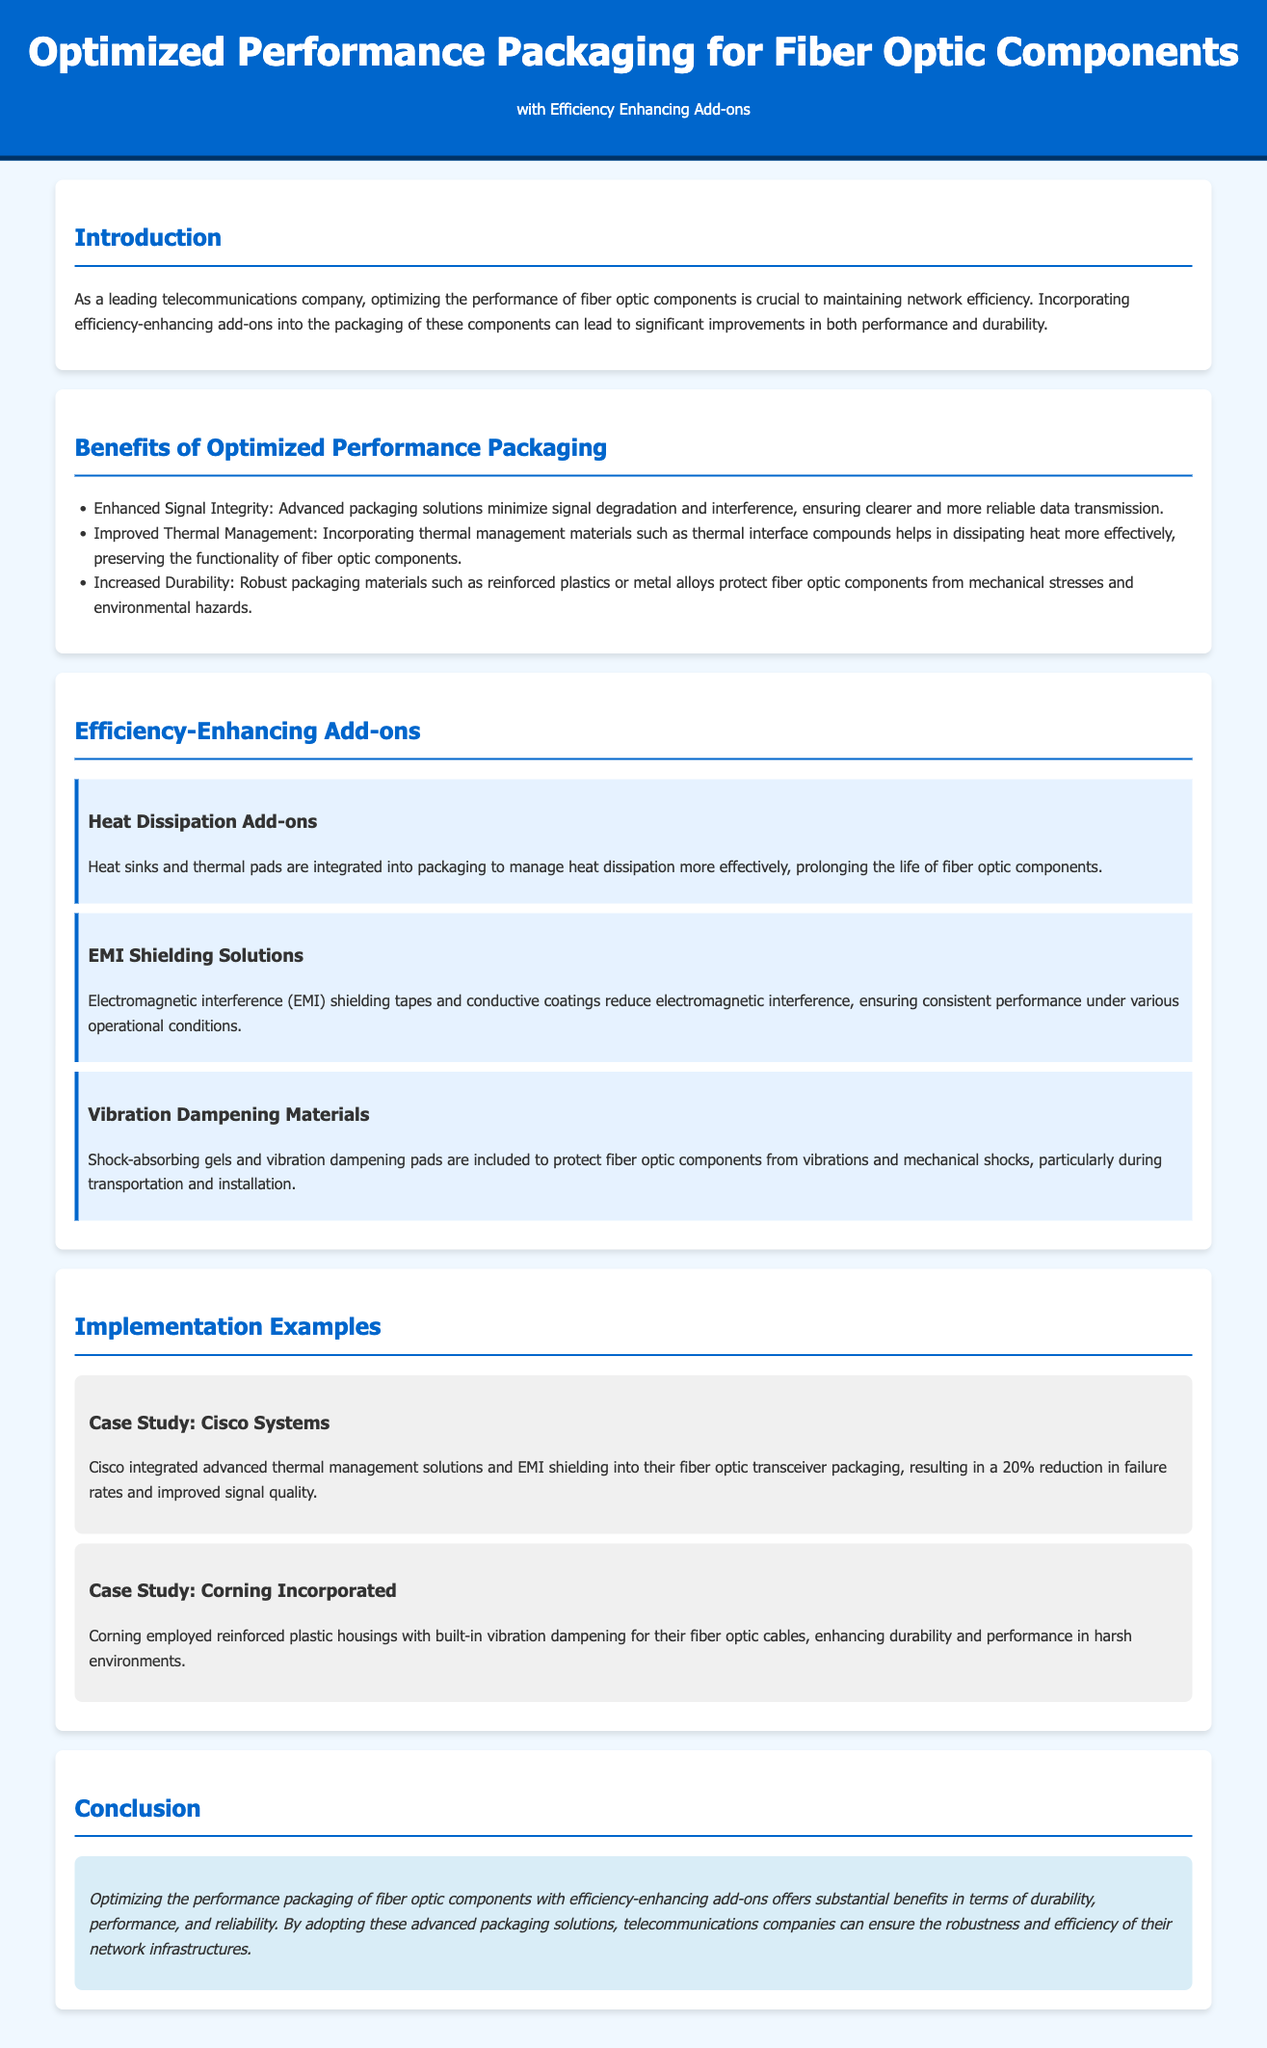What are the primary benefits of optimized performance packaging? The document lists three primary benefits: Enhanced Signal Integrity, Improved Thermal Management, and Increased Durability.
Answer: Enhanced Signal Integrity, Improved Thermal Management, Increased Durability What type of materials help with thermal management? The document mentions that thermal management materials include thermal interface compounds.
Answer: Thermal interface compounds How much did Cisco reduce their failure rates by implementing these solutions? The case study about Cisco Systems states a 20% reduction in failure rates after integration.
Answer: 20% What does EMI stand for in the context of the add-ons provided? The document references Electromagnetic interference (EMI) in relation to shielding solutions.
Answer: Electromagnetic interference Which company used reinforced plastic housings for their fiber optic cables? The case study about Corning Incorporated indicates the use of reinforced plastic housings.
Answer: Corning Incorporated What are the names of the three efficiency-enhancing add-ons mentioned? The document lists Heat Dissipation Add-ons, EMI Shielding Solutions, and Vibration Dampening Materials as the efficiency-enhancing add-ons.
Answer: Heat Dissipation Add-ons, EMI Shielding Solutions, Vibration Dampening Materials What feature aims to reduce electromagnetic interference? The document mentions EMI Shielding Solutions are designed to reduce electromagnetic interference.
Answer: EMI Shielding Solutions What is the purpose of vibration dampening materials? The document states that vibration dampening materials protect fiber optic components from vibrations and mechanical shocks.
Answer: Protect from vibrations and mechanical shocks 